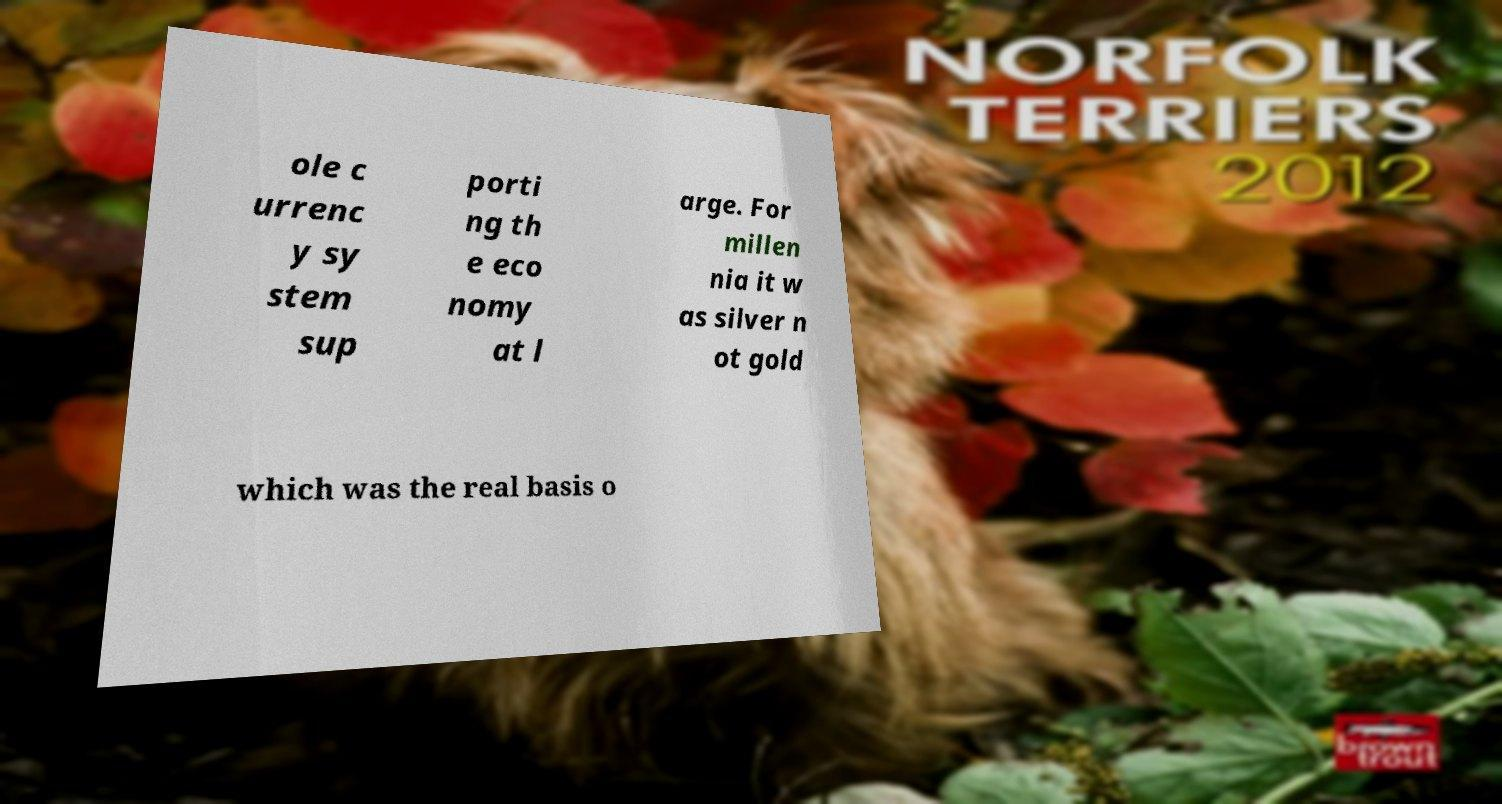Could you extract and type out the text from this image? ole c urrenc y sy stem sup porti ng th e eco nomy at l arge. For millen nia it w as silver n ot gold which was the real basis o 